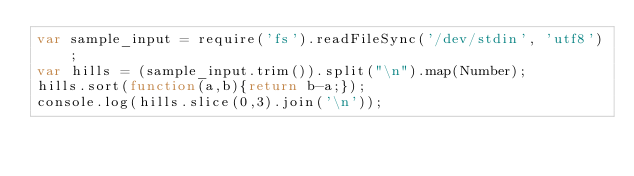Convert code to text. <code><loc_0><loc_0><loc_500><loc_500><_JavaScript_>var sample_input = require('fs').readFileSync('/dev/stdin', 'utf8');
var hills = (sample_input.trim()).split("\n").map(Number);
hills.sort(function(a,b){return b-a;});
console.log(hills.slice(0,3).join('\n'));
</code> 